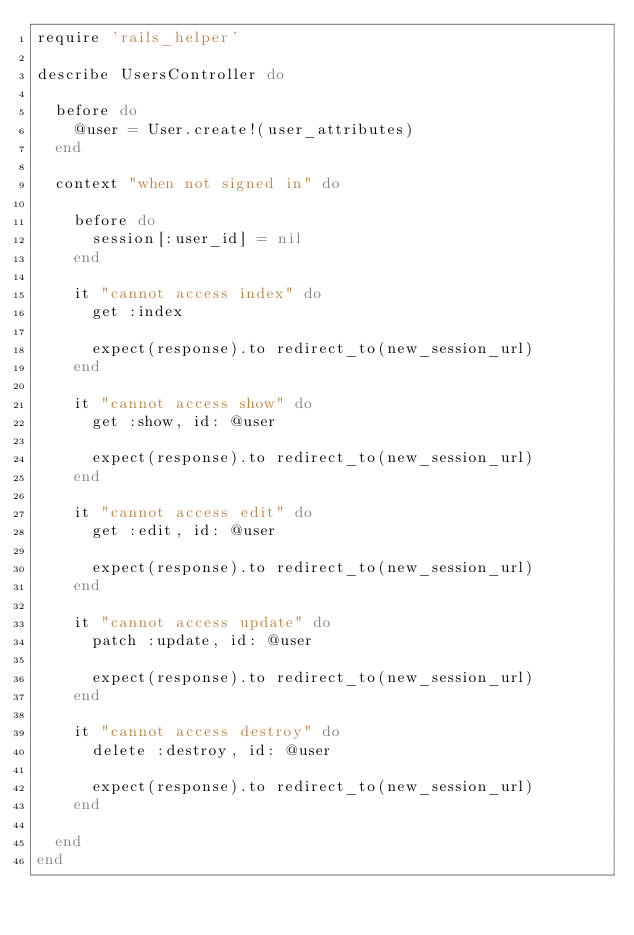Convert code to text. <code><loc_0><loc_0><loc_500><loc_500><_Ruby_>require 'rails_helper'

describe UsersController do

  before do
    @user = User.create!(user_attributes)
  end

  context "when not signed in" do

    before do
      session[:user_id] = nil
    end

    it "cannot access index" do
      get :index

      expect(response).to redirect_to(new_session_url)
    end

    it "cannot access show" do
      get :show, id: @user

      expect(response).to redirect_to(new_session_url)
    end

    it "cannot access edit" do
      get :edit, id: @user

      expect(response).to redirect_to(new_session_url)
    end

    it "cannot access update" do
      patch :update, id: @user

      expect(response).to redirect_to(new_session_url)
    end

    it "cannot access destroy" do
      delete :destroy, id: @user

      expect(response).to redirect_to(new_session_url)
    end

  end
end</code> 